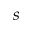<formula> <loc_0><loc_0><loc_500><loc_500>s</formula> 